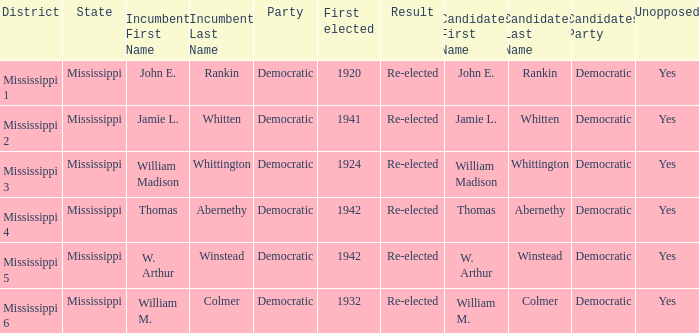Which district is jamie l. whitten from? Mississippi 2. 